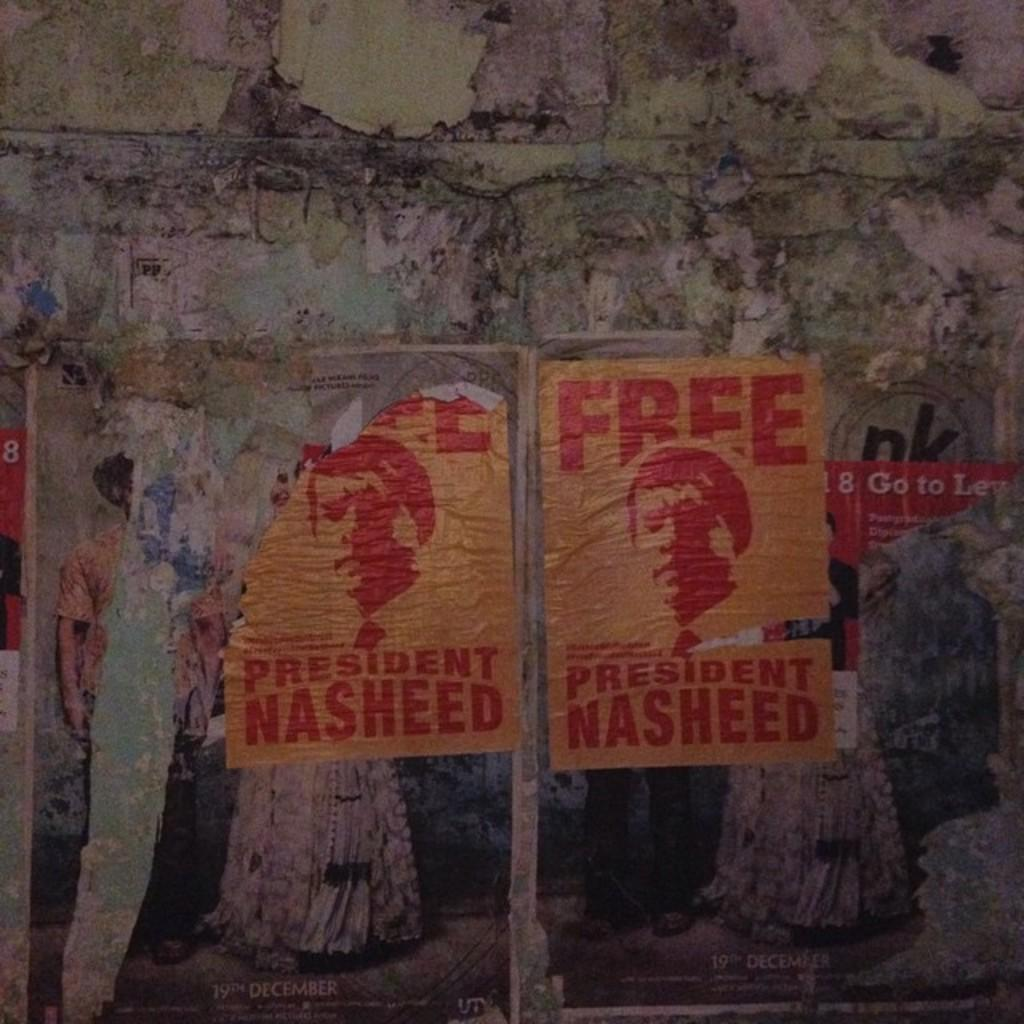<image>
Offer a succinct explanation of the picture presented. Free president Nasheed signs are posted on a wall 